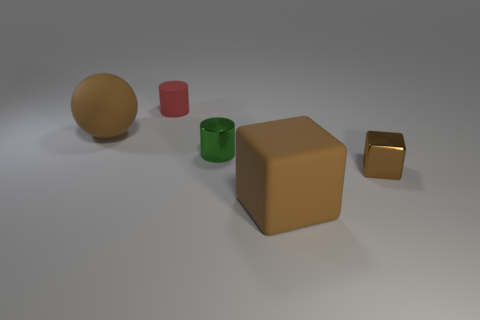There is a tiny thing that is the same color as the big rubber ball; what shape is it?
Offer a terse response. Cube. How many spheres are either tiny green rubber things or small things?
Provide a succinct answer. 0. Does the brown rubber block have the same size as the brown thing that is on the left side of the green shiny cylinder?
Offer a very short reply. Yes. Is the number of brown metallic cubes that are behind the metallic cylinder greater than the number of brown cubes?
Offer a very short reply. No. The block that is made of the same material as the tiny red cylinder is what size?
Offer a very short reply. Large. Is there a small metallic thing of the same color as the tiny matte cylinder?
Offer a very short reply. No. How many things are metal cylinders or tiny things in front of the brown sphere?
Provide a short and direct response. 2. Are there more small red matte cylinders than large rubber things?
Your answer should be compact. No. What is the size of the metal cube that is the same color as the large rubber ball?
Provide a short and direct response. Small. Is there a tiny purple sphere that has the same material as the tiny red object?
Your answer should be compact. No. 